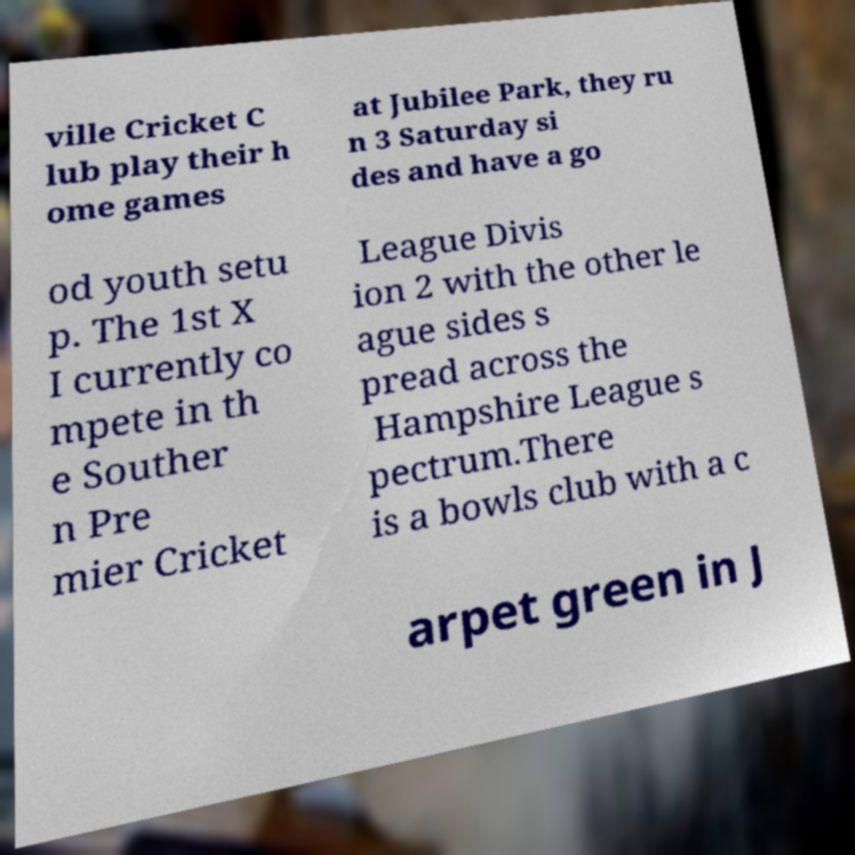Could you assist in decoding the text presented in this image and type it out clearly? ville Cricket C lub play their h ome games at Jubilee Park, they ru n 3 Saturday si des and have a go od youth setu p. The 1st X I currently co mpete in th e Souther n Pre mier Cricket League Divis ion 2 with the other le ague sides s pread across the Hampshire League s pectrum.There is a bowls club with a c arpet green in J 